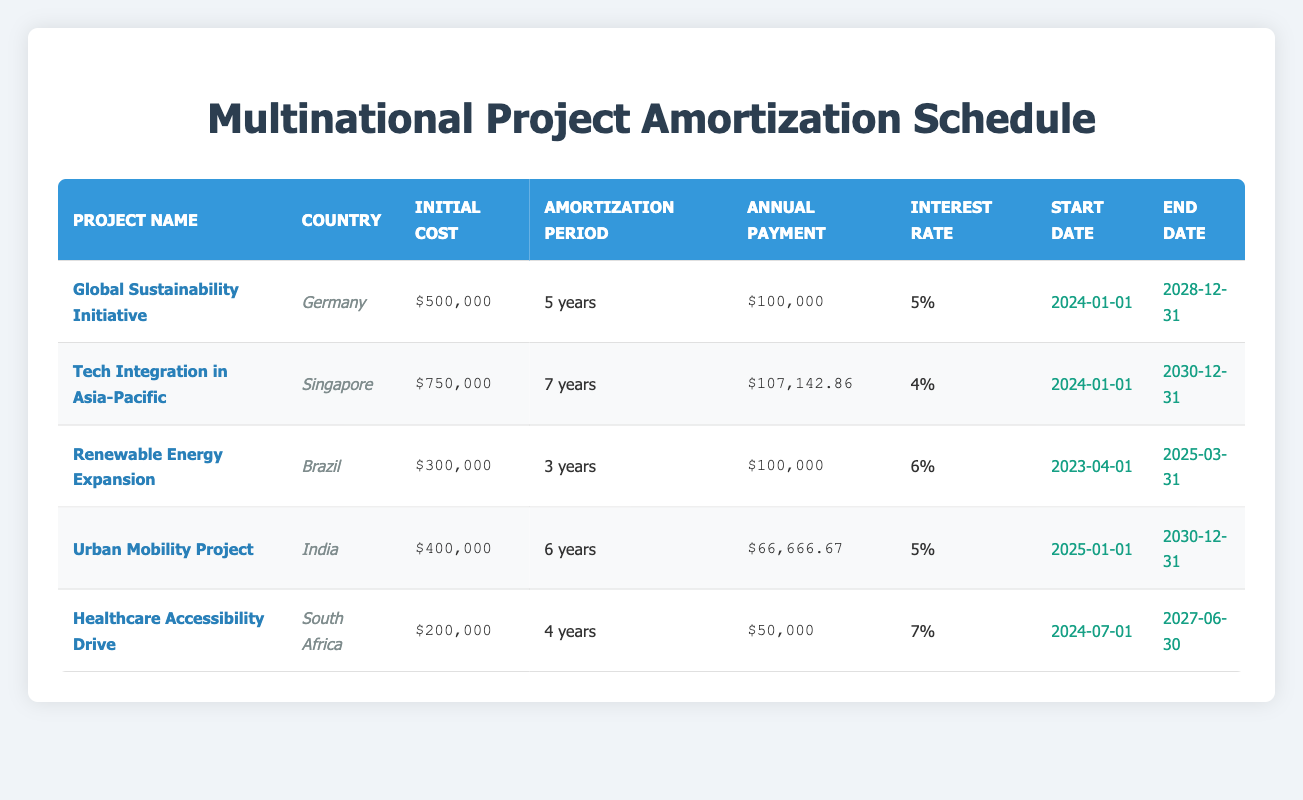What is the initial cost of the "Tech Integration in Asia-Pacific" project? The initial cost for the "Tech Integration in Asia-Pacific" project is listed in the corresponding row of the table. By looking at that row, we can see it is $750,000.
Answer: $750,000 Which project has the longest amortization period? To find the longest amortization period, I compare the values in the "Amortization Period" column. The project "Tech Integration in Asia-Pacific" has an amortization period of 7 years, which is longer than all other projects listed.
Answer: Tech Integration in Asia-Pacific What is the total initial cost of the projects listed in Germany and Brazil? The initial costs for the projects in Germany and Brazil are summed. For Germany, the cost is $500,000 (Global Sustainability Initiative) and for Brazil, it is $300,000 (Renewable Energy Expansion). Thus, the total is $500,000 + $300,000 = $800,000.
Answer: $800,000 Is the interest rate for the "Healthcare Accessibility Drive" project higher than 6 percent? The interest rate for the "Healthcare Accessibility Drive" project is 7 percent. By checking this value against 6 percent, it is confirmed that 7 percent is higher.
Answer: Yes What is the average annual payment of all projects? To find the average annual payment, I add up all the annual payments: $100,000 (Germany) + $107,142.86 (Singapore) + $100,000 (Brazil) + $66,666.67 (India) + $50,000 (South Africa) = $423,809.53. There are 5 projects, so the average is $423,809.53 / 5 = $84,761.91.
Answer: $84,761.91 Which country has the earliest project start date? To find the earliest start date, I compare the dates in the "Start Date" column. The earliest date listed is "2023-04-01" for the Brazil project (Renewable Energy Expansion).
Answer: Brazil How many projects have an annual payment greater than $100,000? By reviewing the "Annual Payment" column, the projects with payments greater than $100,000 are: "Tech Integration in Asia-Pacific" ($107,142.86) and "Global Sustainability Initiative" ($100,000). Only one project exceeds this amount.
Answer: 1 